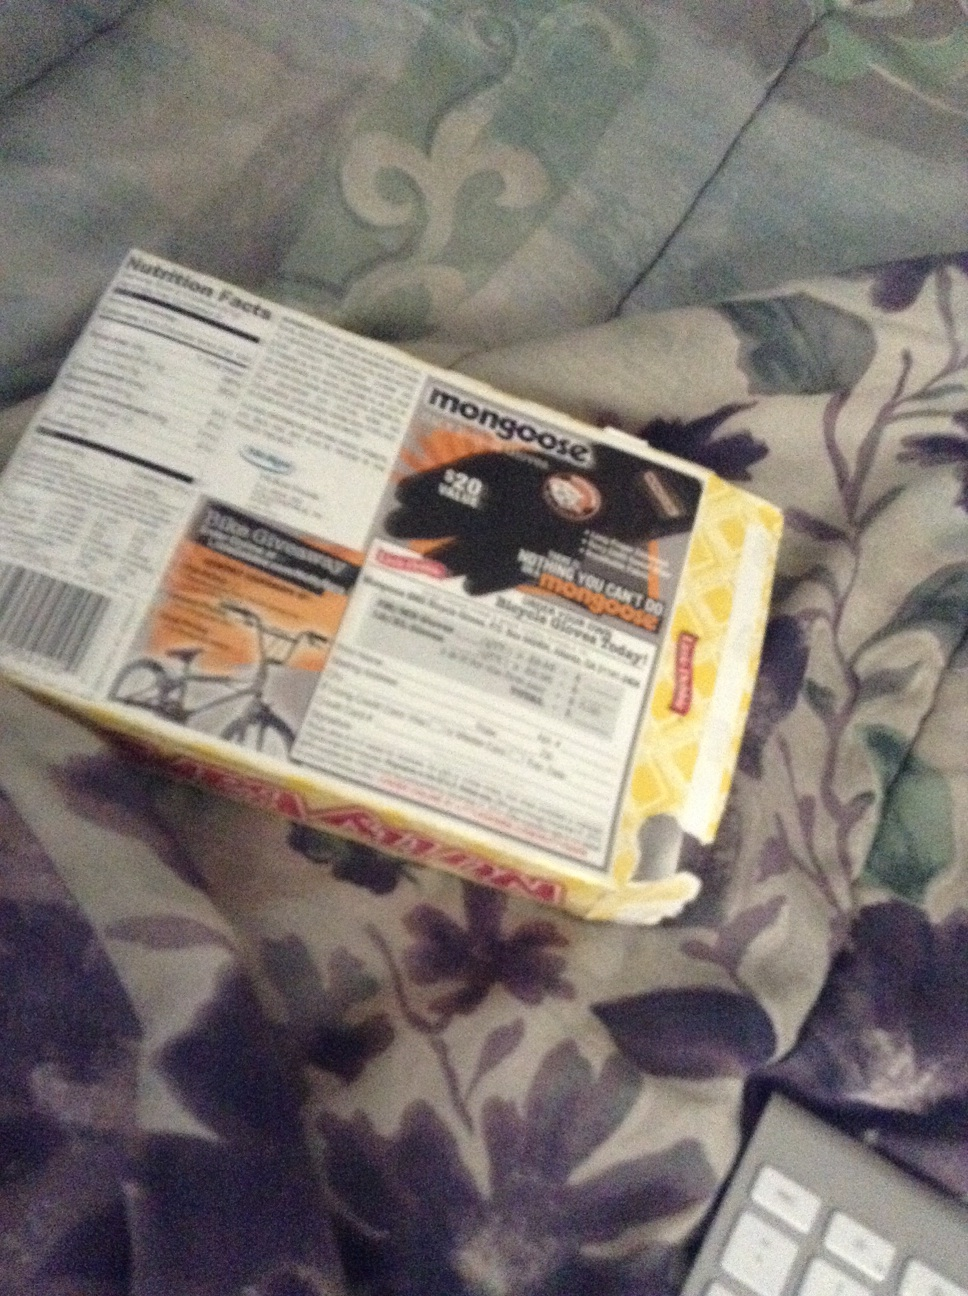What can you tell me about the different features mentioned on this product box? The box showcases Mongoose cycling gloves which have 20 features, as claimed by the packaging. It hints at the gloves being versatile and possibly all-weather friendly. The packaging also contains nutritional facts, which could be on another product that might have been encased in this box. Pay attention to the safety instructions and product details before use. How does this product compare to other cycling gloves in the market? Mongoose cycling gloves are renowned for their durability and comfort. They claim to have 20 unique features, which might include various aspects of ergonomic design, moisture control, and possibly enhanced grip. When compared to other cycling gloves on the market, the Mongoose brand is often praised for its sturdy construction and effectiveness in various weather conditions. Can you describe a scenario where these gloves might be especially useful? Imagine a mountain biking adventure on a rugged trail. The path is full of twists and turns, and the weather is unpredictable. In this scenario, having a pair of sturdy Mongoose cycling gloves can be incredibly helpful. These gloves provide a strong grip on the handlebars, protect the hands from blisters, and offer a degree of weather protection, keeping the hands relatively dry and comfortable throughout the journey. If these gloves were capable of magical powers, what kind of abilities would they have? In a world of magic, these Mongoose gloves could be enchanted with extraordinary abilities. Imagine gloves that could instantly adapt to any weather condition, providing perfect warmth in the cold and excellent cooling in the heat. They could give the wearer supernatural grip and control over the bicycle, allowing swift navigation through the most daunting landscapes. Maybe the gloves would even offer healing properties, mending any cuts or bruises instantly, making the rider almost invincible on their biking journeys. 